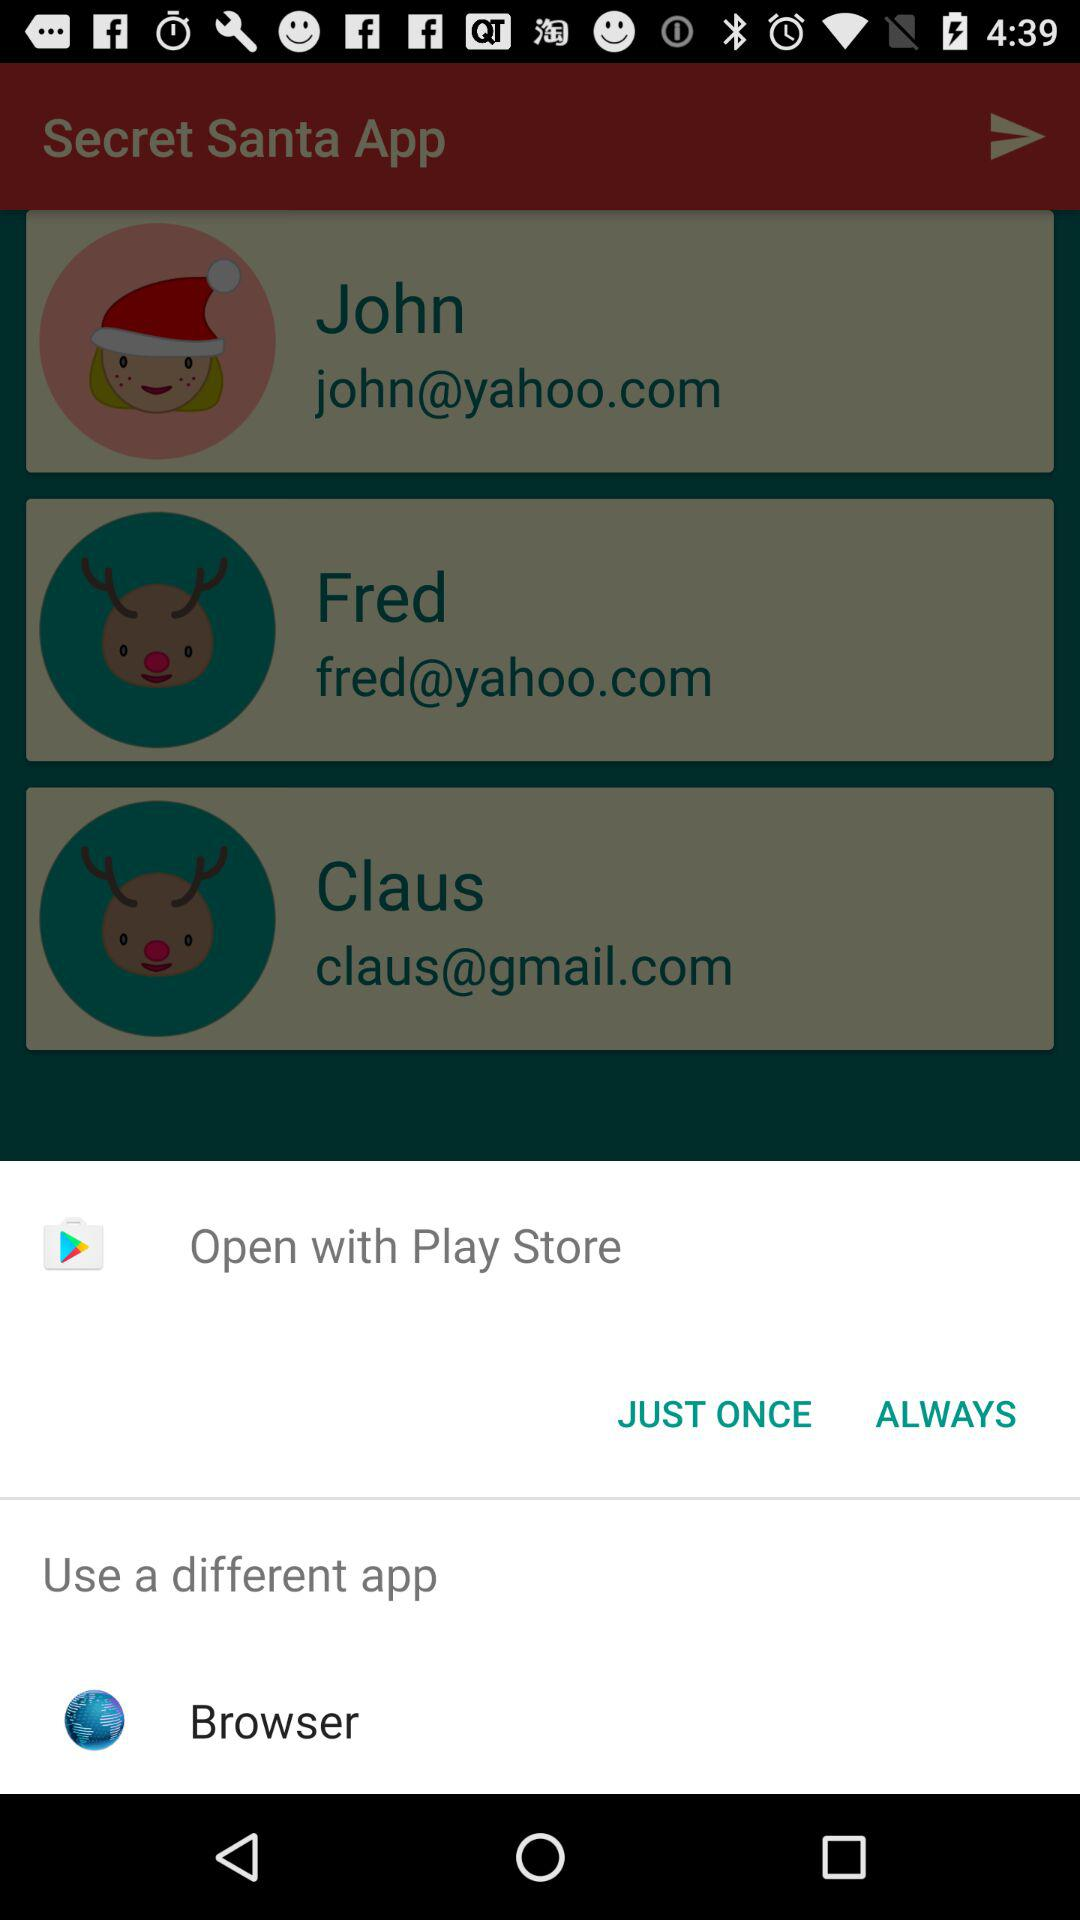What applications can I use to share? The applications are "Play Store" and "Browser". 